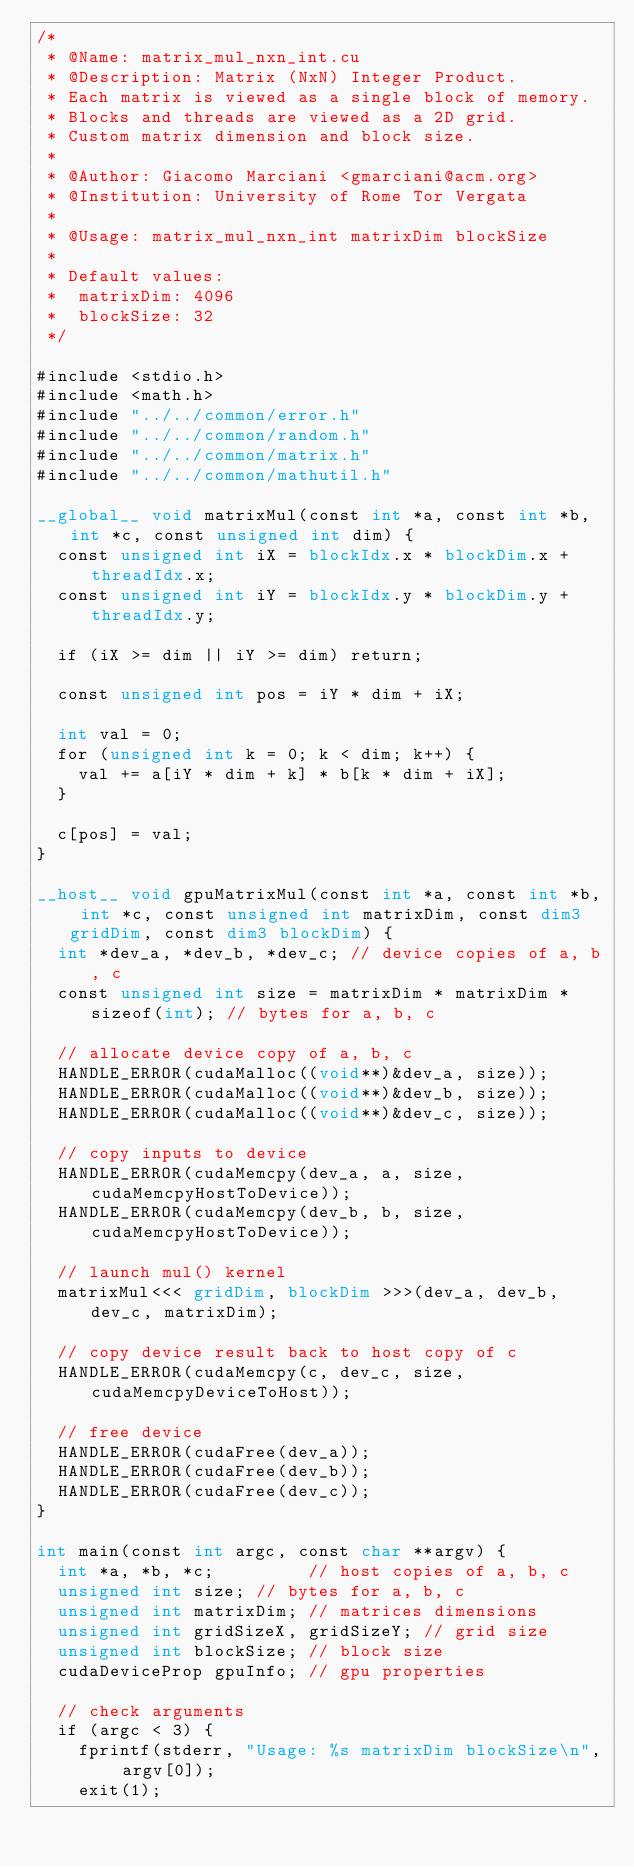Convert code to text. <code><loc_0><loc_0><loc_500><loc_500><_Cuda_>/*
 * @Name: matrix_mul_nxn_int.cu
 * @Description: Matrix (NxN) Integer Product.
 * Each matrix is viewed as a single block of memory.
 * Blocks and threads are viewed as a 2D grid.
 * Custom matrix dimension and block size.
 *
 * @Author: Giacomo Marciani <gmarciani@acm.org>
 * @Institution: University of Rome Tor Vergata
 *
 * @Usage: matrix_mul_nxn_int matrixDim blockSize
 *
 * Default values:
 *  matrixDim: 4096
 *  blockSize: 32
 */

#include <stdio.h>
#include <math.h>
#include "../../common/error.h"
#include "../../common/random.h"
#include "../../common/matrix.h"
#include "../../common/mathutil.h"

__global__ void matrixMul(const int *a, const int *b, int *c, const unsigned int dim) {
  const unsigned int iX = blockIdx.x * blockDim.x + threadIdx.x;
  const unsigned int iY = blockIdx.y * blockDim.y + threadIdx.y;

  if (iX >= dim || iY >= dim) return;

  const unsigned int pos = iY * dim + iX;

  int val = 0;
  for (unsigned int k = 0; k < dim; k++) {
    val += a[iY * dim + k] * b[k * dim + iX];
  }

  c[pos] = val;
}

__host__ void gpuMatrixMul(const int *a, const int *b, int *c, const unsigned int matrixDim, const dim3 gridDim, const dim3 blockDim) {
  int *dev_a, *dev_b, *dev_c; // device copies of a, b, c
  const unsigned int size = matrixDim * matrixDim * sizeof(int); // bytes for a, b, c

  // allocate device copy of a, b, c
  HANDLE_ERROR(cudaMalloc((void**)&dev_a, size));
  HANDLE_ERROR(cudaMalloc((void**)&dev_b, size));
  HANDLE_ERROR(cudaMalloc((void**)&dev_c, size));

  // copy inputs to device
  HANDLE_ERROR(cudaMemcpy(dev_a, a, size, cudaMemcpyHostToDevice));
  HANDLE_ERROR(cudaMemcpy(dev_b, b, size, cudaMemcpyHostToDevice));

  // launch mul() kernel
  matrixMul<<< gridDim, blockDim >>>(dev_a, dev_b, dev_c, matrixDim);

  // copy device result back to host copy of c
  HANDLE_ERROR(cudaMemcpy(c, dev_c, size, cudaMemcpyDeviceToHost));

  // free device
  HANDLE_ERROR(cudaFree(dev_a));
  HANDLE_ERROR(cudaFree(dev_b));
  HANDLE_ERROR(cudaFree(dev_c));
}

int main(const int argc, const char **argv) {
  int *a, *b, *c;         // host copies of a, b, c
  unsigned int size; // bytes for a, b, c
  unsigned int matrixDim; // matrices dimensions
  unsigned int gridSizeX, gridSizeY; // grid size
  unsigned int blockSize; // block size
  cudaDeviceProp gpuInfo; // gpu properties

  // check arguments
  if (argc < 3) {
    fprintf(stderr, "Usage: %s matrixDim blockSize\n", argv[0]);
    exit(1);</code> 